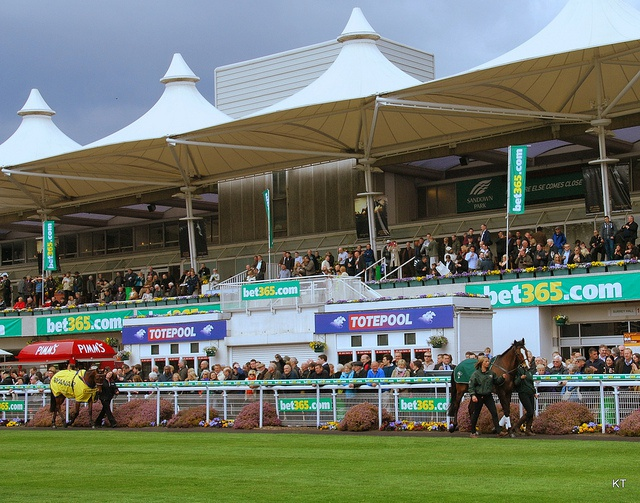Describe the objects in this image and their specific colors. I can see people in darkgray, black, gray, and maroon tones, horse in darkgray, black, khaki, maroon, and olive tones, horse in darkgray, black, maroon, and gray tones, people in darkgray, black, maroon, brown, and gray tones, and people in darkgray, black, gray, and brown tones in this image. 